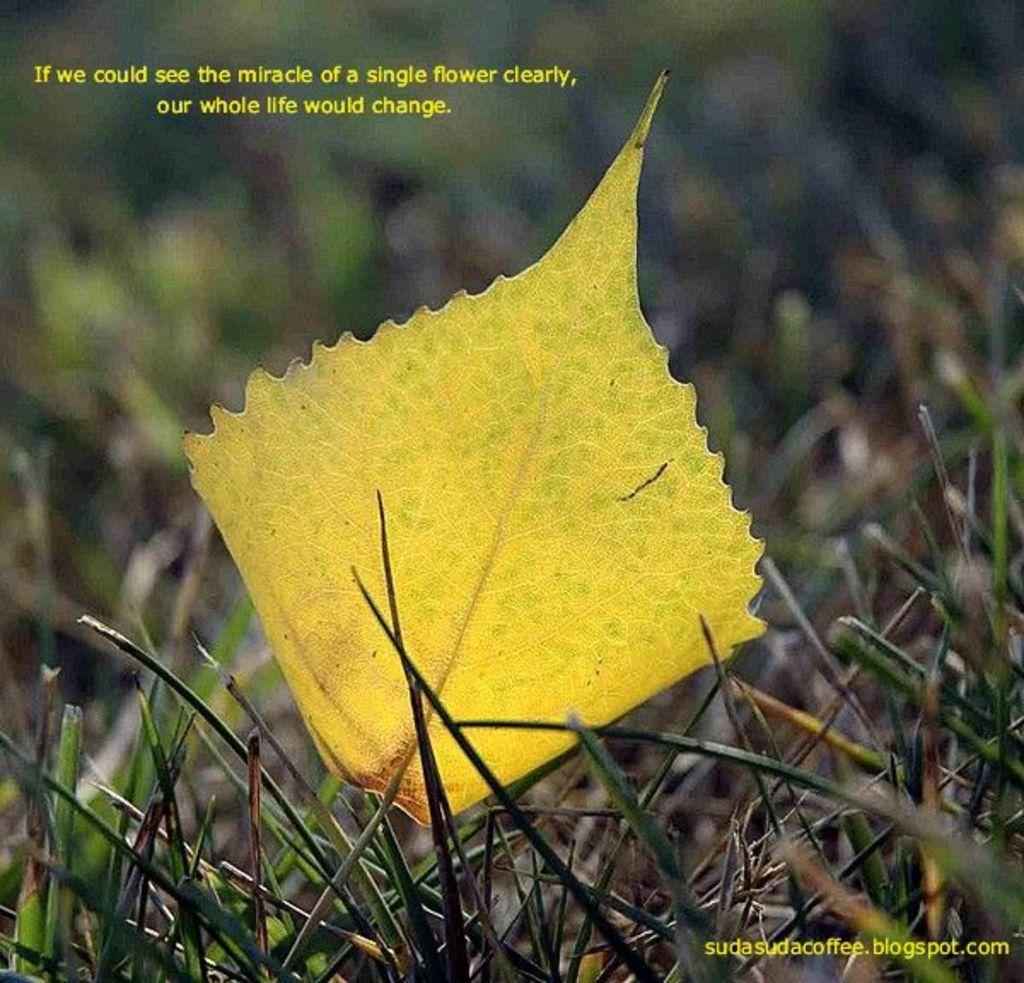What is the main subject in the center of the image? There is a leaf in the center of the image. What else can be seen at the bottom of the image? There are plants at the bottom of the image. Where is the text located in the image? The text is at the top and bottom of the image. What type of flesh can be seen in the image? There is no flesh present in the image; it features a leaf and plants. 